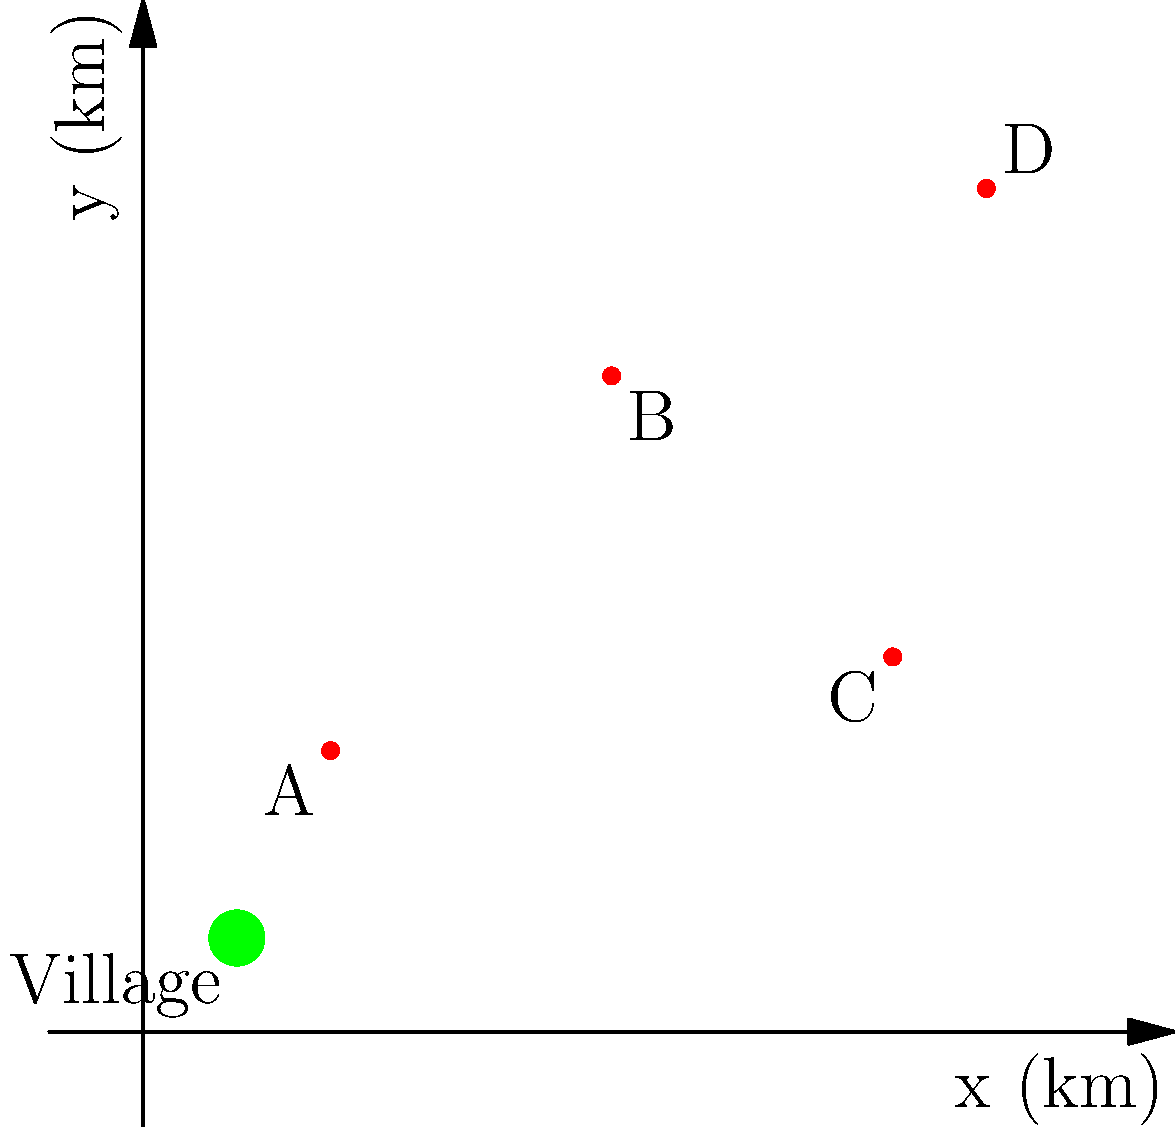During your visit to the tribal area, you've mapped the locations of four important medicinal plants on a 2D coordinate system. The tribal village is located at (1,1). Which medicinal plant is located farthest from the village, and what is its distance from the village (rounded to the nearest kilometer)? To solve this problem, we need to follow these steps:

1. Identify the coordinates of each medicinal plant:
   Plant A: (2,3)
   Plant B: (5,7)
   Plant C: (8,4)
   Plant D: (9,9)

2. Calculate the distance between each plant and the village (1,1) using the distance formula:
   $d = \sqrt{(x_2-x_1)^2 + (y_2-y_1)^2}$

3. For Plant A:
   $d_A = \sqrt{(2-1)^2 + (3-1)^2} = \sqrt{1^2 + 2^2} = \sqrt{5} \approx 2.24$ km

4. For Plant B:
   $d_B = \sqrt{(5-1)^2 + (7-1)^2} = \sqrt{4^2 + 6^2} = \sqrt{52} \approx 7.21$ km

5. For Plant C:
   $d_C = \sqrt{(8-1)^2 + (4-1)^2} = \sqrt{7^2 + 3^2} = \sqrt{58} \approx 7.62$ km

6. For Plant D:
   $d_D = \sqrt{(9-1)^2 + (9-1)^2} = \sqrt{8^2 + 8^2} = \sqrt{128} \approx 11.31$ km

7. Compare the distances:
   Plant D has the largest distance at approximately 11.31 km.

8. Round the distance to the nearest kilometer:
   11.31 km rounds to 11 km.

Therefore, Plant D is located farthest from the village at a distance of 11 km.
Answer: Plant D, 11 km 